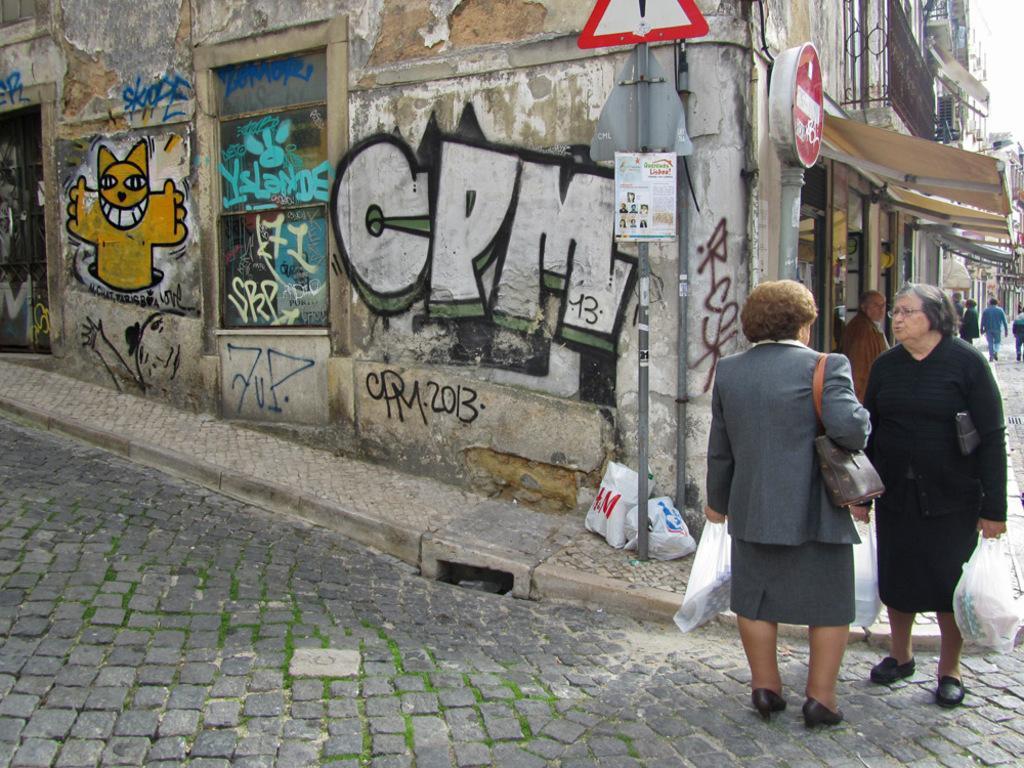Could you give a brief overview of what you see in this image? In this image, there are a few people. Among them, some people are holding some objects. We can see the ground with some objects. We can see the wall with some art. We can see some poles and signboards. We can also see a poster with some images and text. There are a few buildings. We can see the sky. 